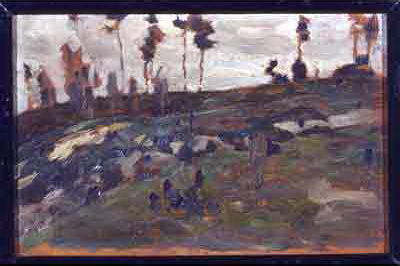Can you describe the emotional tone conveyed by the colors in this painting? The painting employs a somber and earthy color scheme that predominantly features shades of dark brown, gray, and muted green with occasional blues. These choices suggest a mood of melancholy and introspection. The restrained use of vibrant colors enhances the overall feeling of stillness and solemnity, mirroring perhaps the quietude of the natural landscape or the artist's reflective state of mind. 